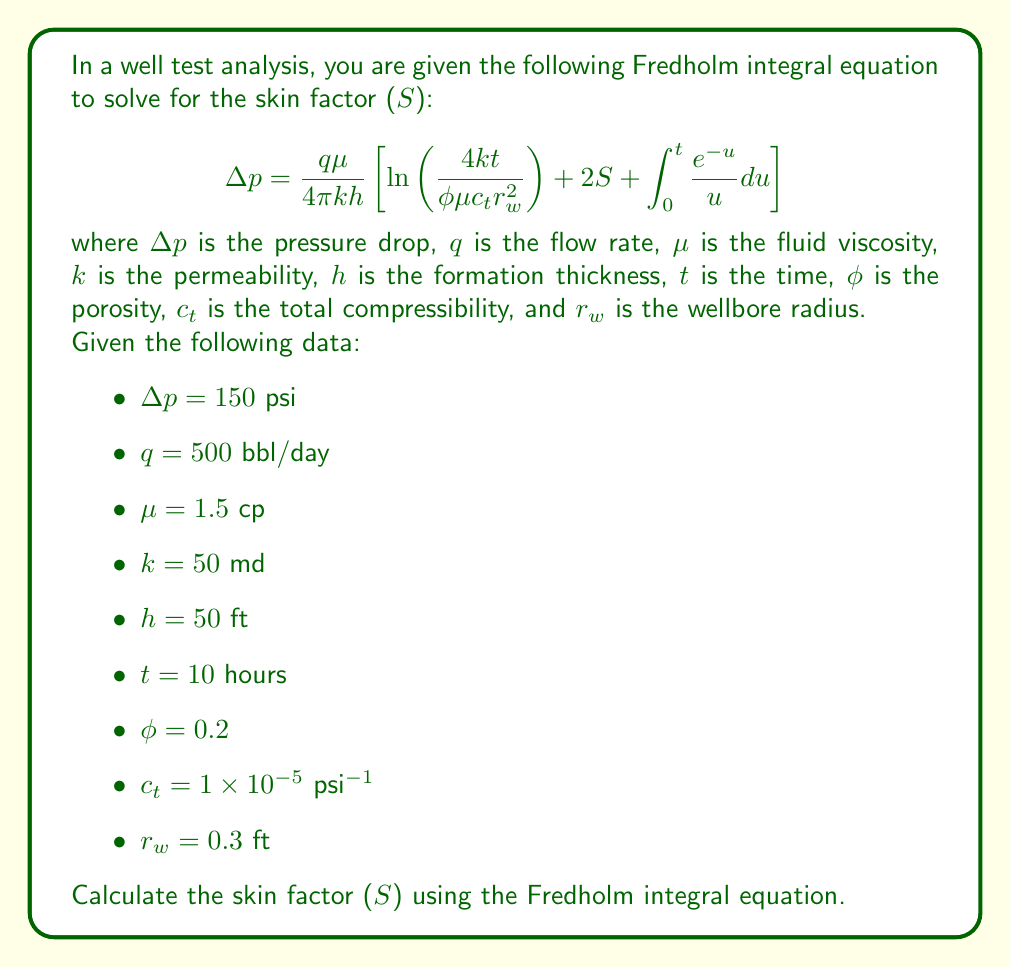Solve this math problem. To solve for the skin factor (S), we'll follow these steps:

1) First, let's simplify the integral term. The integral $\int_0^t \frac{e^{-u}}{u} du$ is known as the exponential integral and is often denoted as $-E_i(-x)$. For large values of $t$, this can be approximated as $\ln(t) + 0.5772$ (Euler's constant).

2) Now, let's rearrange the equation to isolate S:

   $$S = \frac{1}{2}\left[\frac{4\pi kh\Delta p}{q\mu} - \ln\left(\frac{4kt}{\phi\mu c_t r_w^2}\right) - \ln(t) - 0.5772\right]$$

3) Let's calculate the term inside the brackets:

   a) $\frac{4\pi kh\Delta p}{q\mu} = \frac{4\pi \cdot 50 \cdot 50 \cdot 150}{500 \cdot 1.5} = 6283.19$

   b) $\ln\left(\frac{4kt}{\phi\mu c_t r_w^2}\right) = \ln\left(\frac{4 \cdot 50 \cdot 10}{0.2 \cdot 1.5 \cdot 1\times10^{-5} \cdot 0.3^2}\right) = 16.30$

   c) $\ln(t) = \ln(10) = 2.30$

   d) Euler's constant = 0.5772

4) Substituting these values:

   $$S = \frac{1}{2}[6283.19 - 16.30 - 2.30 - 0.5772]$$

5) Simplifying:

   $$S = \frac{1}{2}[6264.01] = 3132.01$$
Answer: $S \approx 3132$ 